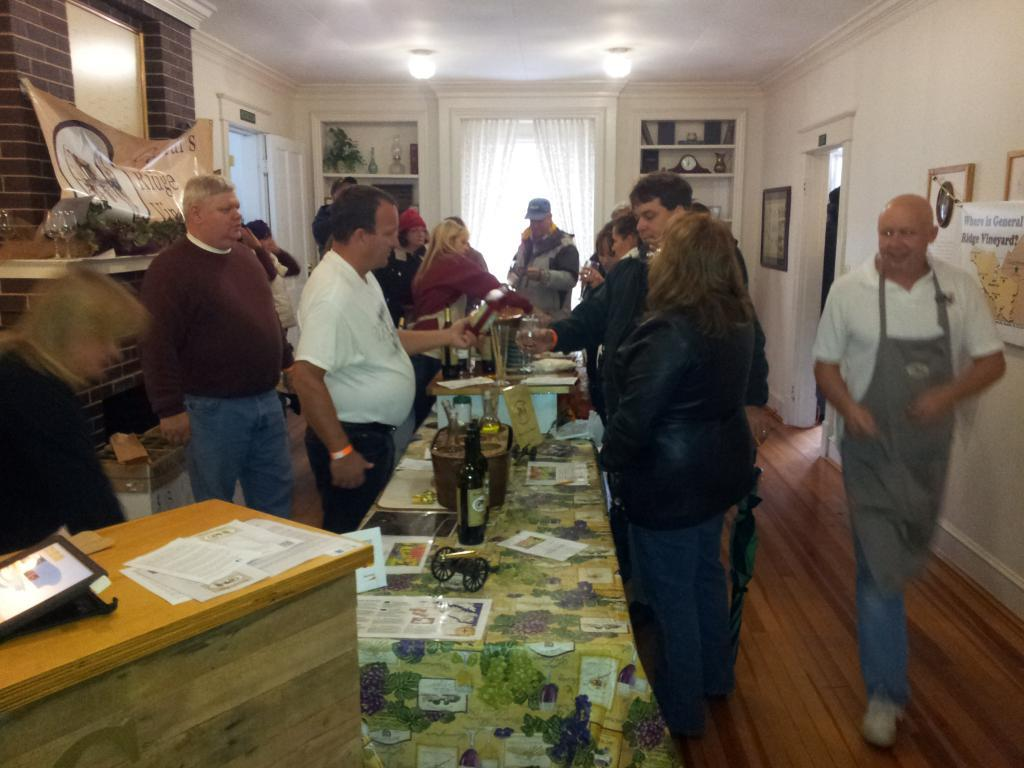What can be seen in the image regarding human presence? There are people standing in the image. Where are the people located in the image? The people are standing on the floor. What furniture is visible in the image? There is a table in the image. What items related to wine can be seen on the table? A wine glass and a wine bottle are present on the table. What type of drum is being played by the slave in the image? There is no slave or drum present in the image. 